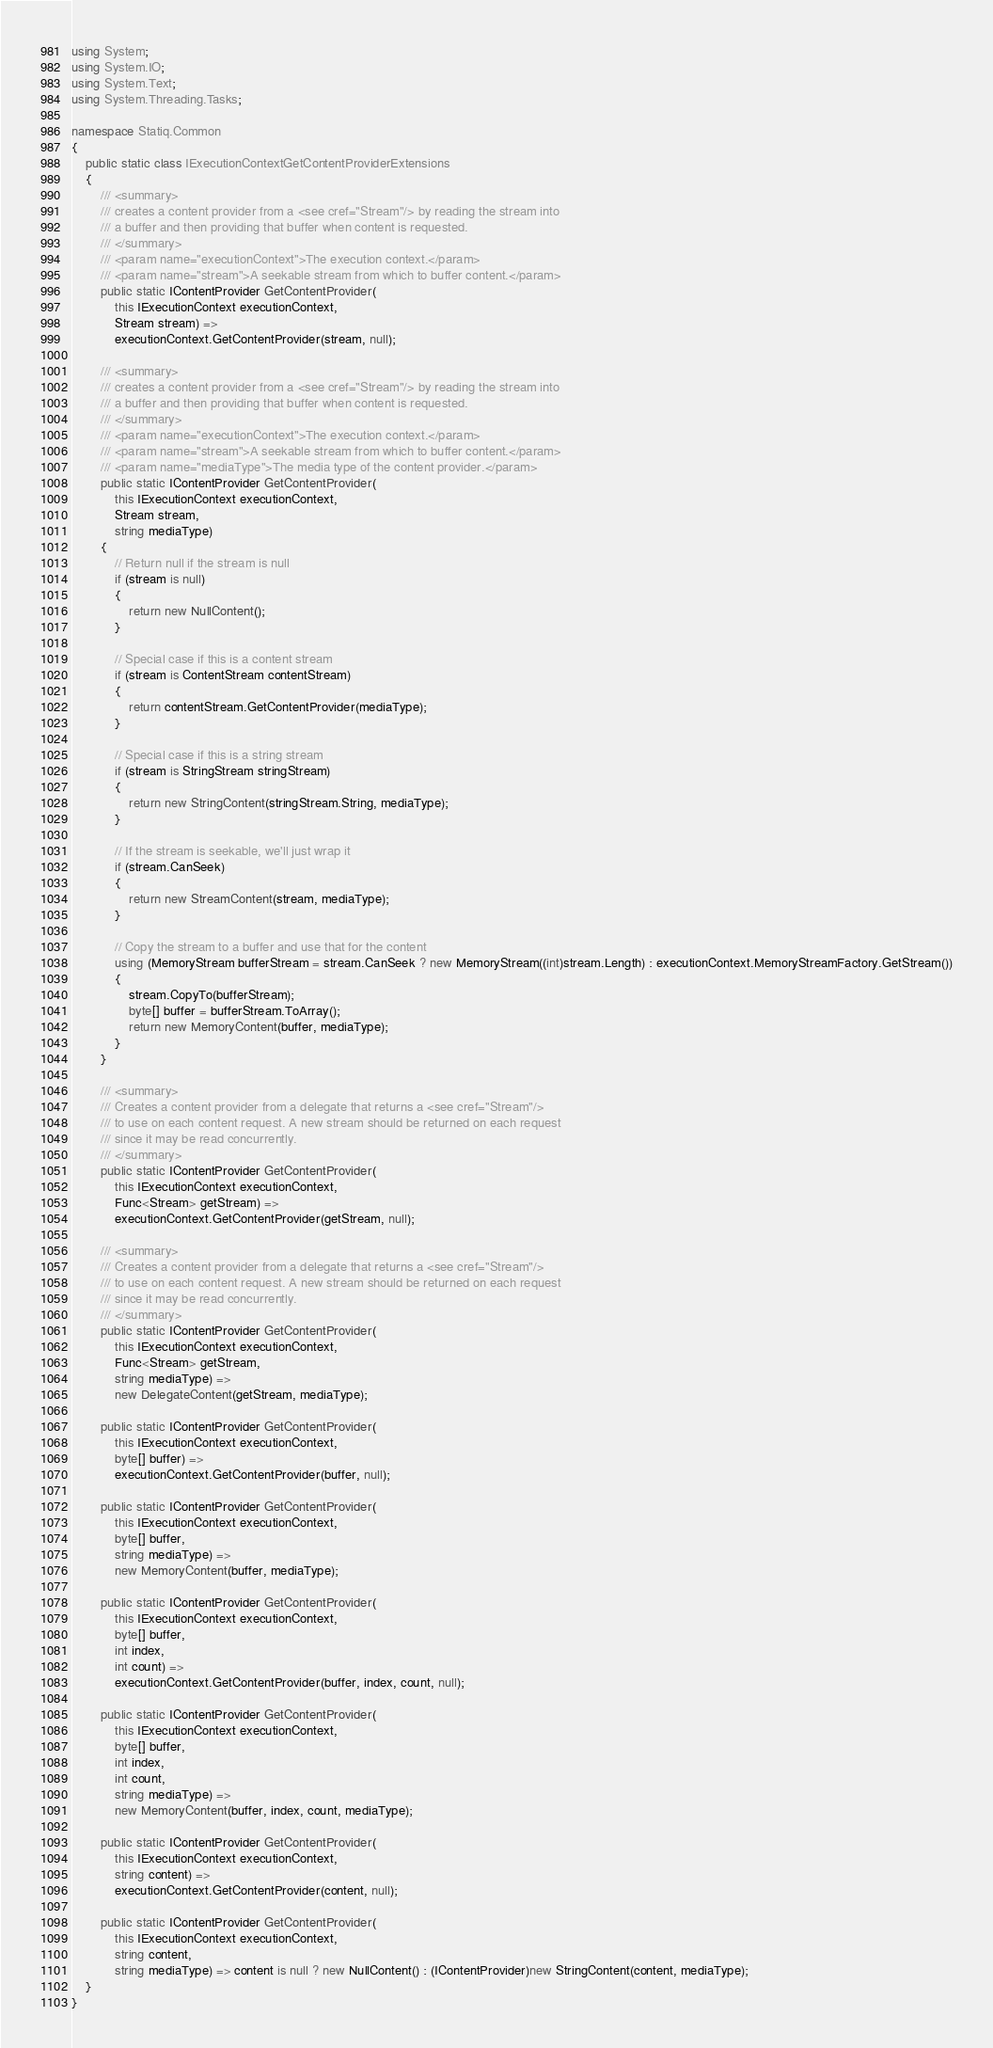<code> <loc_0><loc_0><loc_500><loc_500><_C#_>using System;
using System.IO;
using System.Text;
using System.Threading.Tasks;

namespace Statiq.Common
{
    public static class IExecutionContextGetContentProviderExtensions
    {
        /// <summary>
        /// creates a content provider from a <see cref="Stream"/> by reading the stream into
        /// a buffer and then providing that buffer when content is requested.
        /// </summary>
        /// <param name="executionContext">The execution context.</param>
        /// <param name="stream">A seekable stream from which to buffer content.</param>
        public static IContentProvider GetContentProvider(
            this IExecutionContext executionContext,
            Stream stream) =>
            executionContext.GetContentProvider(stream, null);

        /// <summary>
        /// creates a content provider from a <see cref="Stream"/> by reading the stream into
        /// a buffer and then providing that buffer when content is requested.
        /// </summary>
        /// <param name="executionContext">The execution context.</param>
        /// <param name="stream">A seekable stream from which to buffer content.</param>
        /// <param name="mediaType">The media type of the content provider.</param>
        public static IContentProvider GetContentProvider(
            this IExecutionContext executionContext,
            Stream stream,
            string mediaType)
        {
            // Return null if the stream is null
            if (stream is null)
            {
                return new NullContent();
            }

            // Special case if this is a content stream
            if (stream is ContentStream contentStream)
            {
                return contentStream.GetContentProvider(mediaType);
            }

            // Special case if this is a string stream
            if (stream is StringStream stringStream)
            {
                return new StringContent(stringStream.String, mediaType);
            }

            // If the stream is seekable, we'll just wrap it
            if (stream.CanSeek)
            {
                return new StreamContent(stream, mediaType);
            }

            // Copy the stream to a buffer and use that for the content
            using (MemoryStream bufferStream = stream.CanSeek ? new MemoryStream((int)stream.Length) : executionContext.MemoryStreamFactory.GetStream())
            {
                stream.CopyTo(bufferStream);
                byte[] buffer = bufferStream.ToArray();
                return new MemoryContent(buffer, mediaType);
            }
        }

        /// <summary>
        /// Creates a content provider from a delegate that returns a <see cref="Stream"/>
        /// to use on each content request. A new stream should be returned on each request
        /// since it may be read concurrently.
        /// </summary>
        public static IContentProvider GetContentProvider(
            this IExecutionContext executionContext,
            Func<Stream> getStream) =>
            executionContext.GetContentProvider(getStream, null);

        /// <summary>
        /// Creates a content provider from a delegate that returns a <see cref="Stream"/>
        /// to use on each content request. A new stream should be returned on each request
        /// since it may be read concurrently.
        /// </summary>
        public static IContentProvider GetContentProvider(
            this IExecutionContext executionContext,
            Func<Stream> getStream,
            string mediaType) =>
            new DelegateContent(getStream, mediaType);

        public static IContentProvider GetContentProvider(
            this IExecutionContext executionContext,
            byte[] buffer) =>
            executionContext.GetContentProvider(buffer, null);

        public static IContentProvider GetContentProvider(
            this IExecutionContext executionContext,
            byte[] buffer,
            string mediaType) =>
            new MemoryContent(buffer, mediaType);

        public static IContentProvider GetContentProvider(
            this IExecutionContext executionContext,
            byte[] buffer,
            int index,
            int count) =>
            executionContext.GetContentProvider(buffer, index, count, null);

        public static IContentProvider GetContentProvider(
            this IExecutionContext executionContext,
            byte[] buffer,
            int index,
            int count,
            string mediaType) =>
            new MemoryContent(buffer, index, count, mediaType);

        public static IContentProvider GetContentProvider(
            this IExecutionContext executionContext,
            string content) =>
            executionContext.GetContentProvider(content, null);

        public static IContentProvider GetContentProvider(
            this IExecutionContext executionContext,
            string content,
            string mediaType) => content is null ? new NullContent() : (IContentProvider)new StringContent(content, mediaType);
    }
}
</code> 